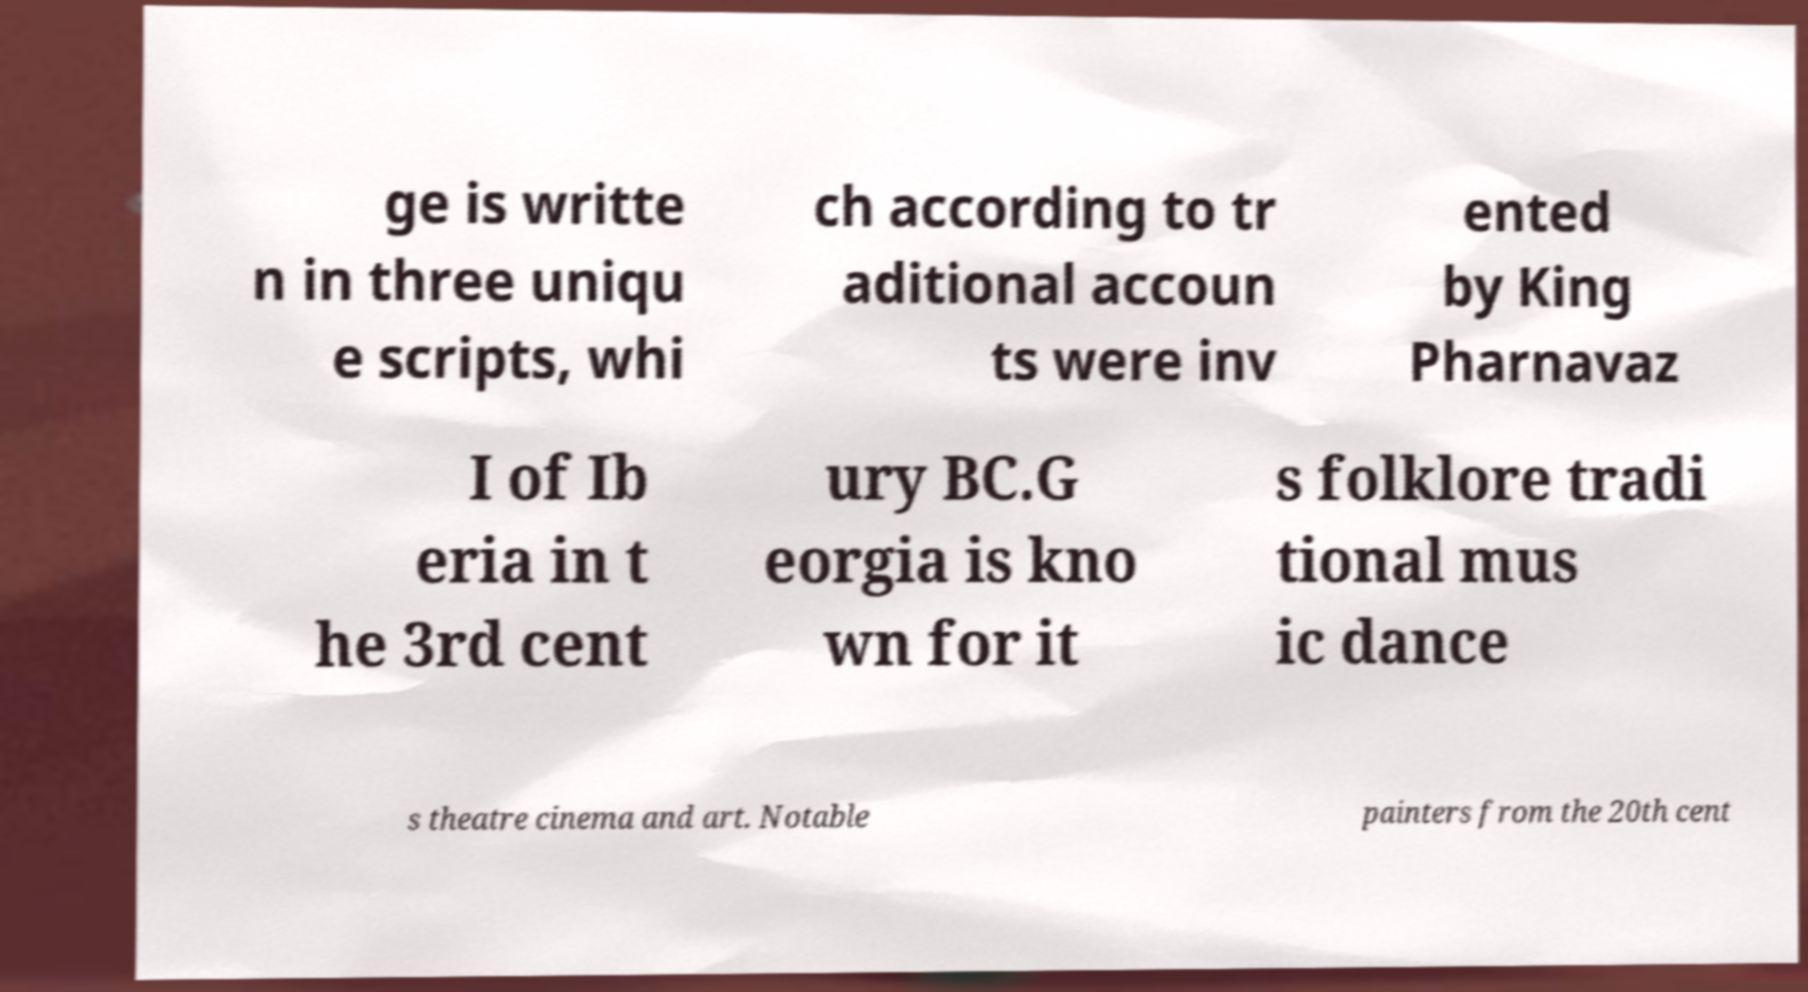Could you extract and type out the text from this image? ge is writte n in three uniqu e scripts, whi ch according to tr aditional accoun ts were inv ented by King Pharnavaz I of Ib eria in t he 3rd cent ury BC.G eorgia is kno wn for it s folklore tradi tional mus ic dance s theatre cinema and art. Notable painters from the 20th cent 